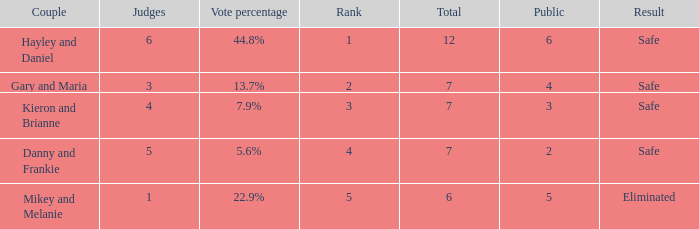How many public is there for the couple that got eliminated? 5.0. 